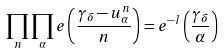<formula> <loc_0><loc_0><loc_500><loc_500>\prod _ { n } \prod _ { \alpha } e \left ( \frac { \gamma _ { \delta } - u _ { \alpha } ^ { n } } { n } \right ) = e ^ { - l } \left ( \frac { \gamma _ { \delta } } { \alpha } \right )</formula> 